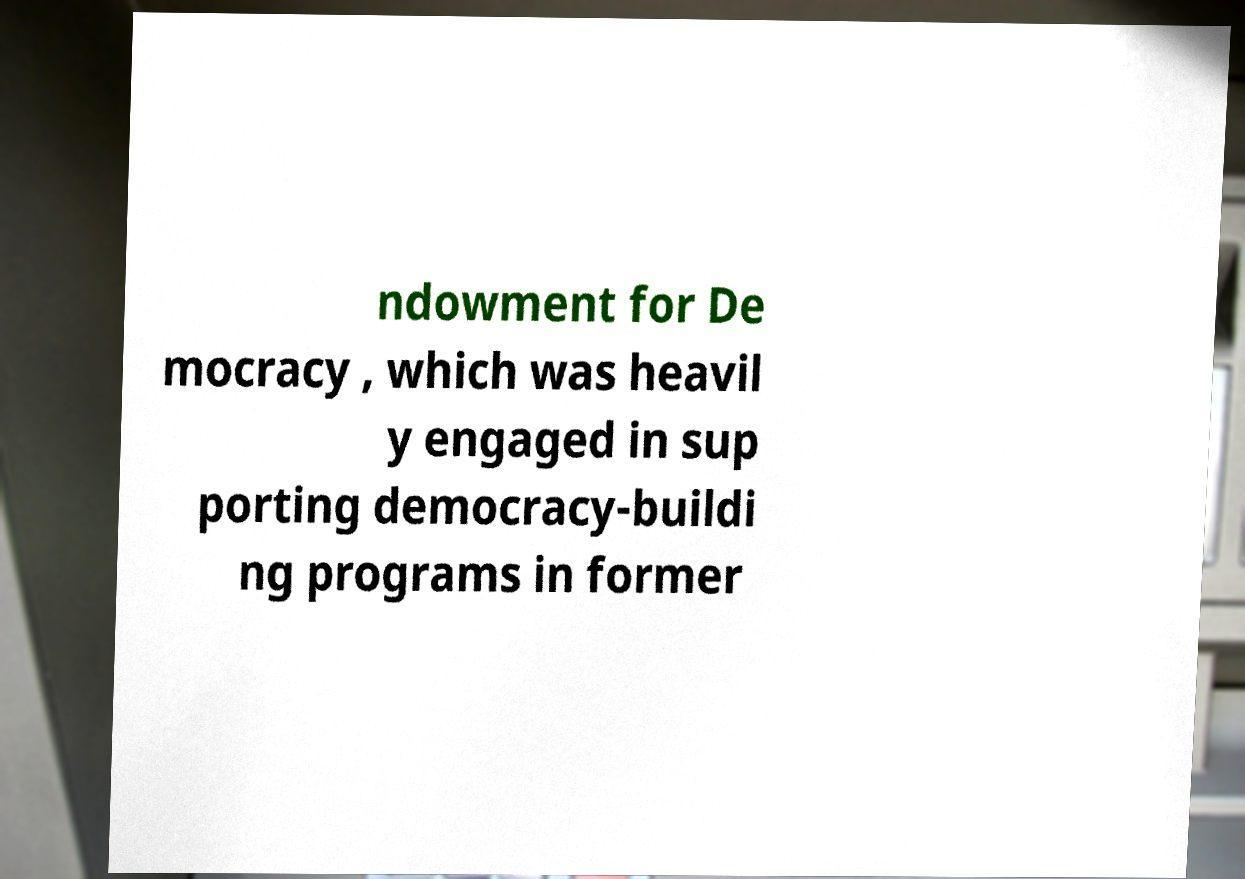There's text embedded in this image that I need extracted. Can you transcribe it verbatim? ndowment for De mocracy , which was heavil y engaged in sup porting democracy-buildi ng programs in former 